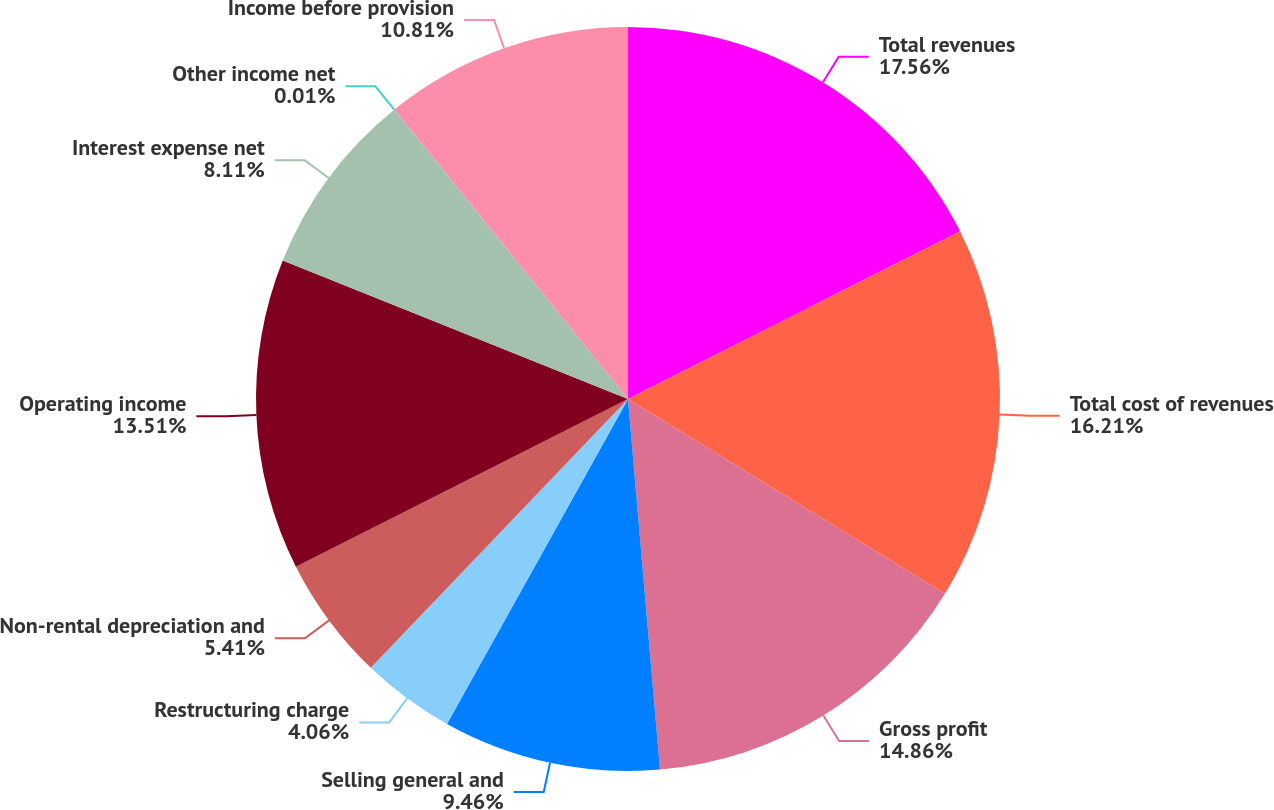<chart> <loc_0><loc_0><loc_500><loc_500><pie_chart><fcel>Total revenues<fcel>Total cost of revenues<fcel>Gross profit<fcel>Selling general and<fcel>Restructuring charge<fcel>Non-rental depreciation and<fcel>Operating income<fcel>Interest expense net<fcel>Other income net<fcel>Income before provision<nl><fcel>17.56%<fcel>16.21%<fcel>14.86%<fcel>9.46%<fcel>4.06%<fcel>5.41%<fcel>13.51%<fcel>8.11%<fcel>0.01%<fcel>10.81%<nl></chart> 